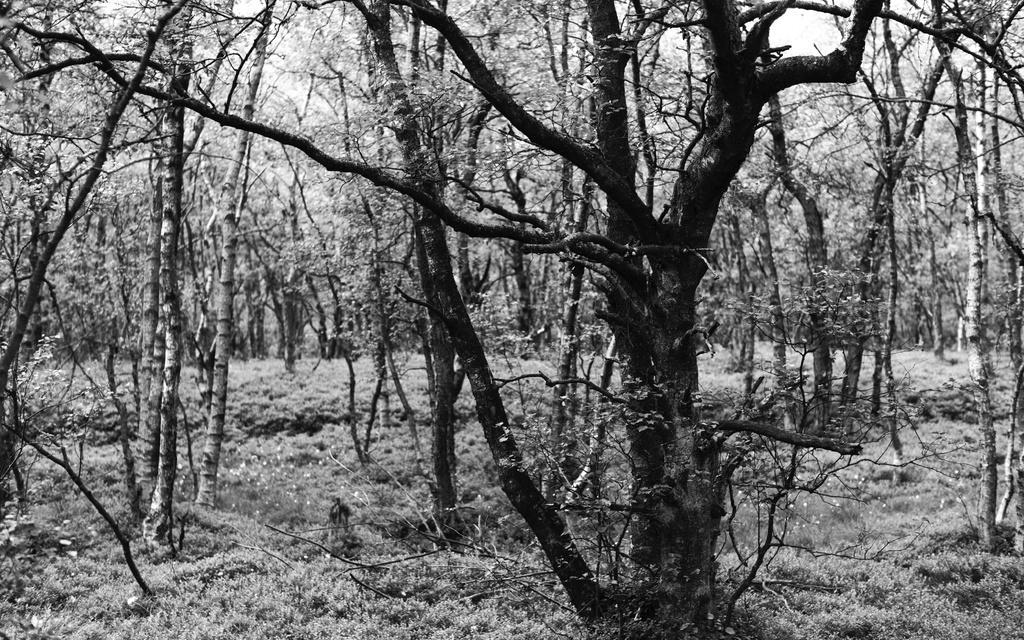In one or two sentences, can you explain what this image depicts? In this image we can see trees, and picture is taken in black and white mode. 